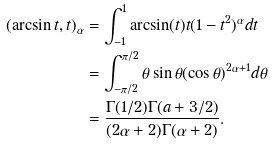<formula> <loc_0><loc_0><loc_500><loc_500>( \arcsin t , t ) _ { \alpha } & = \int _ { - 1 } ^ { 1 } \arcsin ( t ) t ( 1 - t ^ { 2 } ) ^ { \alpha } d t \\ & = \int _ { - \pi / 2 } ^ { \pi / 2 } \theta \sin \theta ( \cos \theta ) ^ { 2 \alpha + 1 } d \theta \\ & = \frac { \Gamma ( 1 / 2 ) \Gamma ( a + 3 / 2 ) } { ( 2 \alpha + 2 ) \Gamma ( \alpha + 2 ) } .</formula> 